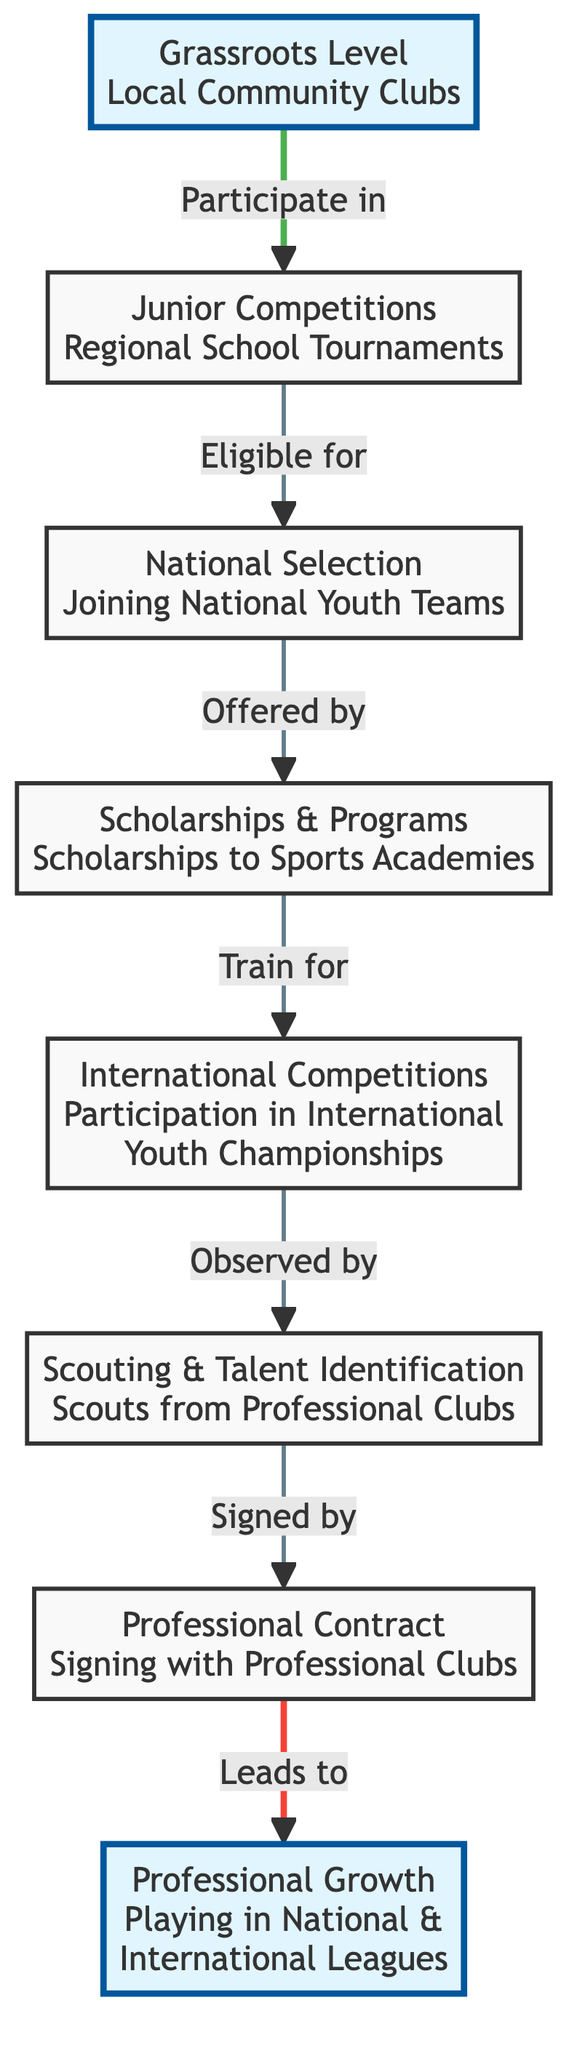What is the first step for athletes in the diagram? The first step is the "Grassroots Level" which involves engagement with local community clubs.
Answer: Grassroots Level How many main steps are shown in the diagram? The diagram has a total of 8 main steps from the grassroots level to professional growth, each represented as a node.
Answer: 8 Which node leads to national selection? The node that leads to national selection is "Junior Competitions" where athletes participate in regional school tournaments.
Answer: Junior Competitions What represents the transition from amateur to professional status? The transition from amateur to professional status is represented by the node "Professional Contract" which involves signing with professional clubs.
Answer: Professional Contract Which step comes after training for international competitions? After training for international competitions, athletes are observed by "Scouting & Talent Identification" teams from professional clubs.
Answer: Scouting & Talent Identification What is the last step in the athlete's career pathway? The last step in the athlete's career pathway is "Professional Growth," which involves playing in national and international leagues.
Answer: Professional Growth What is the relationship between scholarships & programs and international competitions? Scholarships & programs are offered to athletes to train for international competitions, thus they are a prerequisite step before participation in such events.
Answer: Offered by If an athlete successfully signs with a professional club, what does it subsequently lead to? Successfully signing with a professional club leads to "Professional Growth," enabling the athlete to play in national and international leagues.
Answer: Professional Growth 